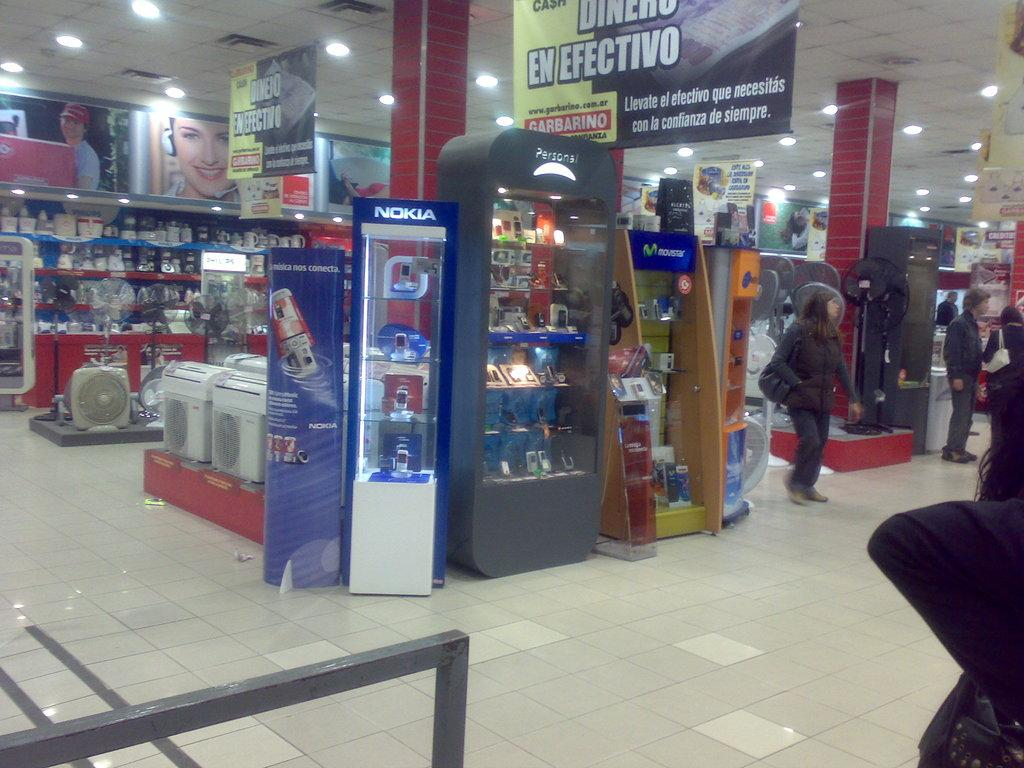<image>
Relay a brief, clear account of the picture shown. A store with many aisles, displays and customers, Nokia being the name on the most prominent display. 